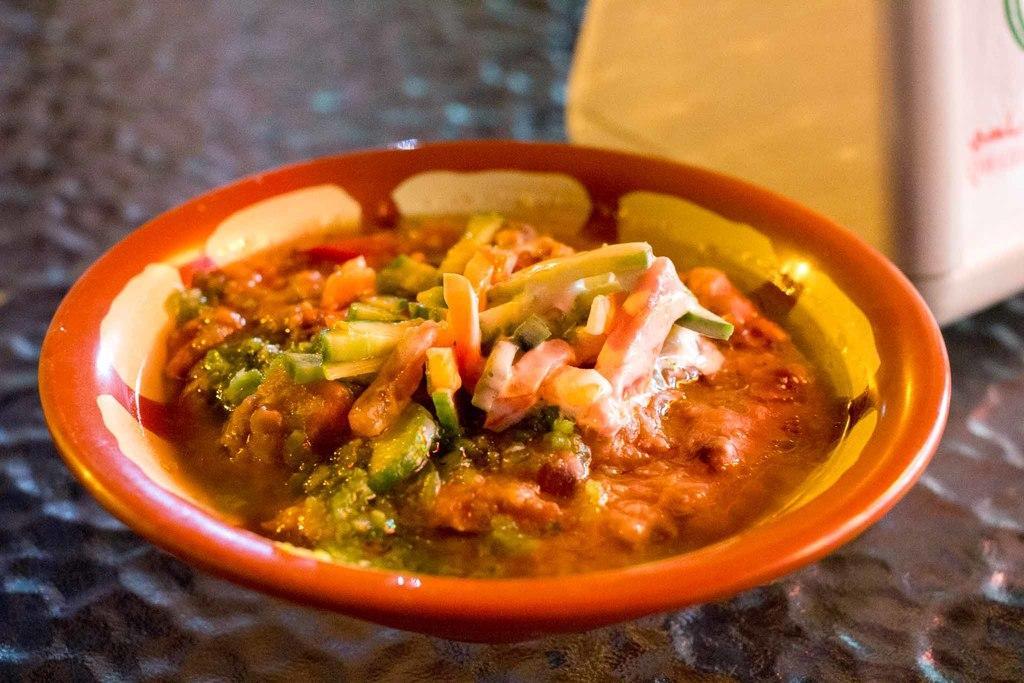Describe this image in one or two sentences. In this picture we can see a bowl, there is some food present in the bowl, on the right side we can see something, there is a blurry background. 